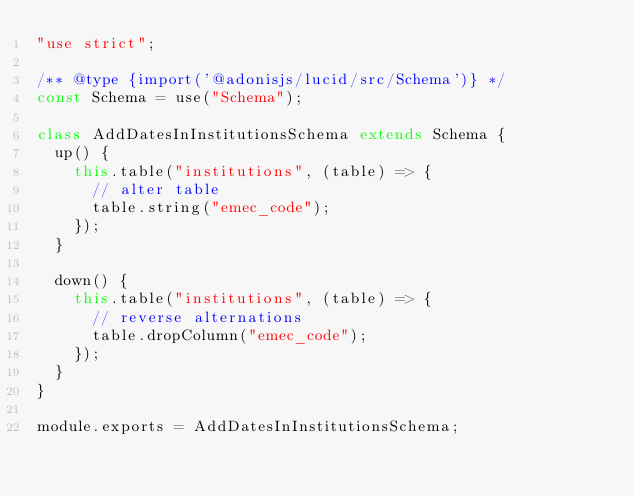Convert code to text. <code><loc_0><loc_0><loc_500><loc_500><_JavaScript_>"use strict";

/** @type {import('@adonisjs/lucid/src/Schema')} */
const Schema = use("Schema");

class AddDatesInInstitutionsSchema extends Schema {
  up() {
    this.table("institutions", (table) => {
      // alter table
      table.string("emec_code");
    });
  }

  down() {
    this.table("institutions", (table) => {
      // reverse alternations
      table.dropColumn("emec_code");
    });
  }
}

module.exports = AddDatesInInstitutionsSchema;
</code> 